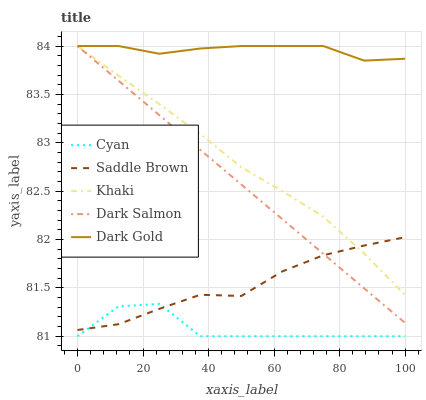Does Cyan have the minimum area under the curve?
Answer yes or no. Yes. Does Dark Gold have the maximum area under the curve?
Answer yes or no. Yes. Does Khaki have the minimum area under the curve?
Answer yes or no. No. Does Khaki have the maximum area under the curve?
Answer yes or no. No. Is Dark Salmon the smoothest?
Answer yes or no. Yes. Is Cyan the roughest?
Answer yes or no. Yes. Is Khaki the smoothest?
Answer yes or no. No. Is Khaki the roughest?
Answer yes or no. No. Does Cyan have the lowest value?
Answer yes or no. Yes. Does Khaki have the lowest value?
Answer yes or no. No. Does Dark Salmon have the highest value?
Answer yes or no. Yes. Does Saddle Brown have the highest value?
Answer yes or no. No. Is Cyan less than Dark Salmon?
Answer yes or no. Yes. Is Dark Salmon greater than Cyan?
Answer yes or no. Yes. Does Saddle Brown intersect Khaki?
Answer yes or no. Yes. Is Saddle Brown less than Khaki?
Answer yes or no. No. Is Saddle Brown greater than Khaki?
Answer yes or no. No. Does Cyan intersect Dark Salmon?
Answer yes or no. No. 